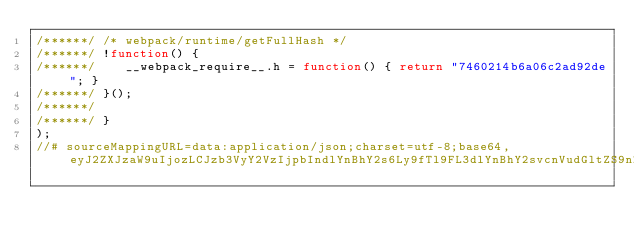<code> <loc_0><loc_0><loc_500><loc_500><_JavaScript_>/******/ /* webpack/runtime/getFullHash */
/******/ !function() {
/******/ 	__webpack_require__.h = function() { return "7460214b6a06c2ad92de"; }
/******/ }();
/******/ 
/******/ }
);
//# sourceMappingURL=data:application/json;charset=utf-8;base64,eyJ2ZXJzaW9uIjozLCJzb3VyY2VzIjpbIndlYnBhY2s6Ly9fTl9FL3dlYnBhY2svcnVudGltZS9nZXRGdWxsSGFzaCJdLCJuYW1lcyI6W10sIm1hcHBpbmdzIjoiOzs7Ozs7VUFBQSxvQ0FBb0MsK0JBQStCLEUiLCJmaWxlIjoic3RhdGljL3dlYnBhY2svd2VicGFjay44Njc4MTJjYTVmZTVhZmU1MTJlMy5ob3QtdXBkYXRlLmpzIiwic291cmNlc0NvbnRlbnQiOlsiX193ZWJwYWNrX3JlcXVpcmVfXy5oID0gZnVuY3Rpb24oKSB7IHJldHVybiBcIjc0NjAyMTRiNmEwNmMyYWQ5MmRlXCI7IH0iXSwic291cmNlUm9vdCI6IiJ9</code> 